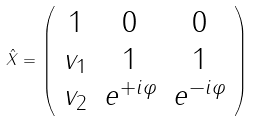Convert formula to latex. <formula><loc_0><loc_0><loc_500><loc_500>\hat { X } = \left ( \begin{array} { c c c } 1 & 0 & 0 \\ v _ { 1 } & 1 & 1 \\ v _ { 2 } & e ^ { + i \varphi } & e ^ { - i \varphi } \end{array} \right )</formula> 